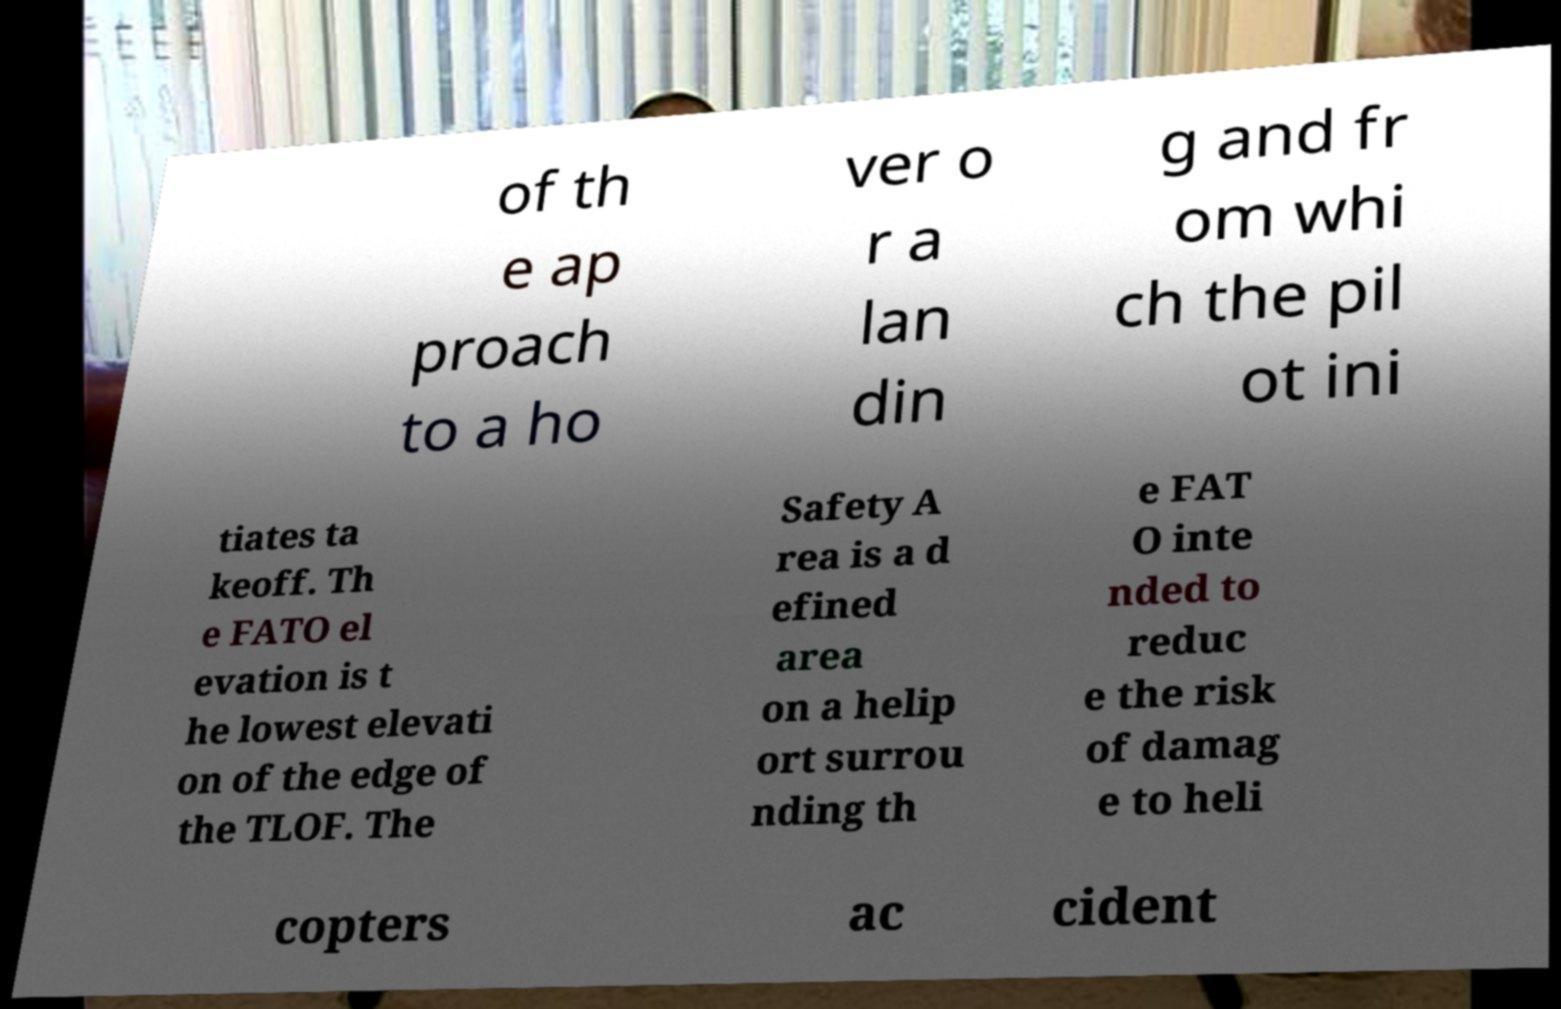I need the written content from this picture converted into text. Can you do that? of th e ap proach to a ho ver o r a lan din g and fr om whi ch the pil ot ini tiates ta keoff. Th e FATO el evation is t he lowest elevati on of the edge of the TLOF. The Safety A rea is a d efined area on a helip ort surrou nding th e FAT O inte nded to reduc e the risk of damag e to heli copters ac cident 